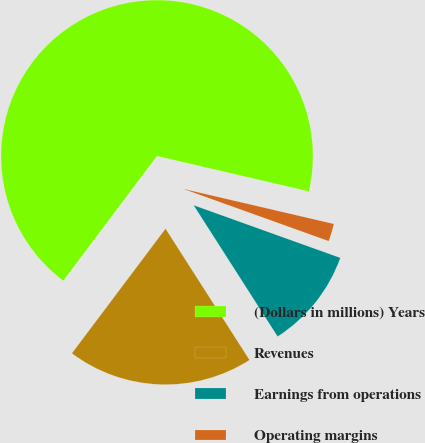<chart> <loc_0><loc_0><loc_500><loc_500><pie_chart><fcel>(Dollars in millions) Years<fcel>Revenues<fcel>Earnings from operations<fcel>Operating margins<nl><fcel>68.39%<fcel>19.31%<fcel>10.46%<fcel>1.84%<nl></chart> 